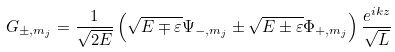<formula> <loc_0><loc_0><loc_500><loc_500>G _ { \pm , m _ { j } } = \frac { 1 } { \sqrt { 2 E } } \left ( \sqrt { E \mp \varepsilon } \Psi _ { - , m _ { j } } \pm \sqrt { E \pm \varepsilon } \Phi _ { + , m _ { j } } \right ) \frac { e ^ { i k z } } { \sqrt { L } }</formula> 